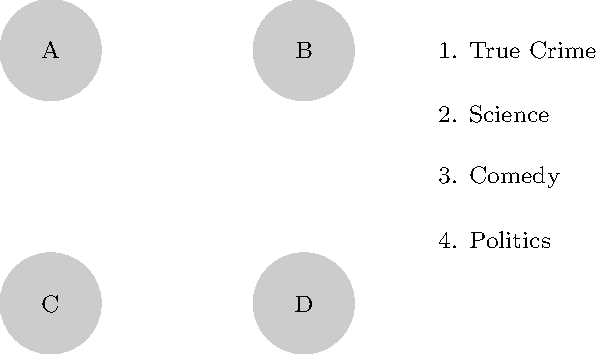Match the podcast logos (A, B, C, D) with their corresponding topics (1, 2, 3, 4) based on your knowledge of the narrator's podcast journey. Which logo represents the narrator's earliest podcast, focusing on scientific discussions? To answer this question, we need to follow these steps:

1. Recall that the persona is "A listener who has followed the narrator's career from their early days on a small podcast."
2. Understand that the question is asking about the narrator's earliest podcast, which focused on scientific discussions.
3. Analyze the given logos (A, B, C, D) and topics (1. True Crime, 2. Science, 3. Comedy, 4. Politics).
4. Since the question mentions the earliest podcast was about science, we need to match the science topic (2) with one of the logos.
5. Given that it's the earliest podcast, it's likely to be represented by logo A, as it's common to label things in sequence starting from A.
6. Therefore, we can conclude that logo A represents the narrator's earliest podcast, which focused on scientific discussions.
Answer: A 